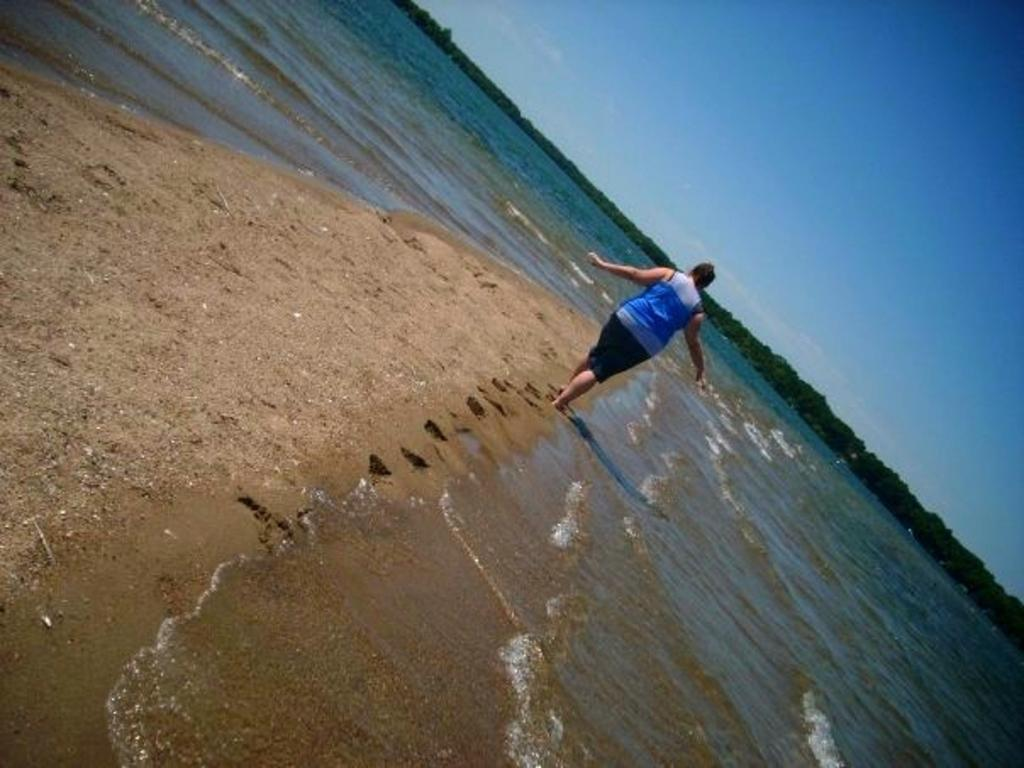What is the person in the image doing? There is a person walking in the image. What can be seen behind the person? There is water visible behind the person. What is in the background of the image? There is a group of trees in the background of the image. What part of the sky is visible in the image? The sky is visible in the top right corner of the image. What type of rice is being used to hold the door open in the image? There is no rice or door present in the image. 